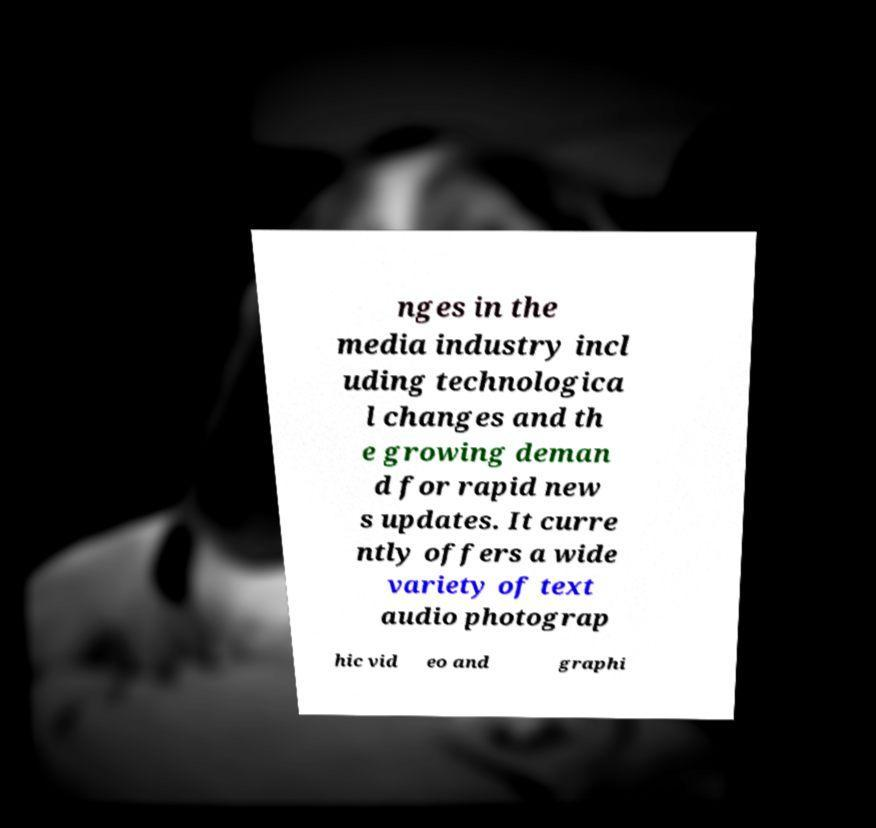There's text embedded in this image that I need extracted. Can you transcribe it verbatim? nges in the media industry incl uding technologica l changes and th e growing deman d for rapid new s updates. It curre ntly offers a wide variety of text audio photograp hic vid eo and graphi 